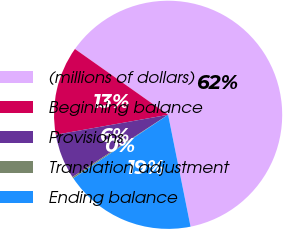<chart> <loc_0><loc_0><loc_500><loc_500><pie_chart><fcel>(millions of dollars)<fcel>Beginning balance<fcel>Provisions<fcel>Translation adjustment<fcel>Ending balance<nl><fcel>62.06%<fcel>12.58%<fcel>6.39%<fcel>0.21%<fcel>18.76%<nl></chart> 